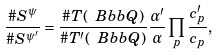Convert formula to latex. <formula><loc_0><loc_0><loc_500><loc_500>\frac { \# S ^ { \psi } } { \# S ^ { \psi ^ { \prime } } } = \frac { \# T ( \ B b b Q ) } { \# T ^ { \prime } ( \ B b b Q ) } \frac { \alpha ^ { \prime } } { \alpha } \prod _ { p } \frac { c _ { p } ^ { \prime } } { c _ { p } } ,</formula> 